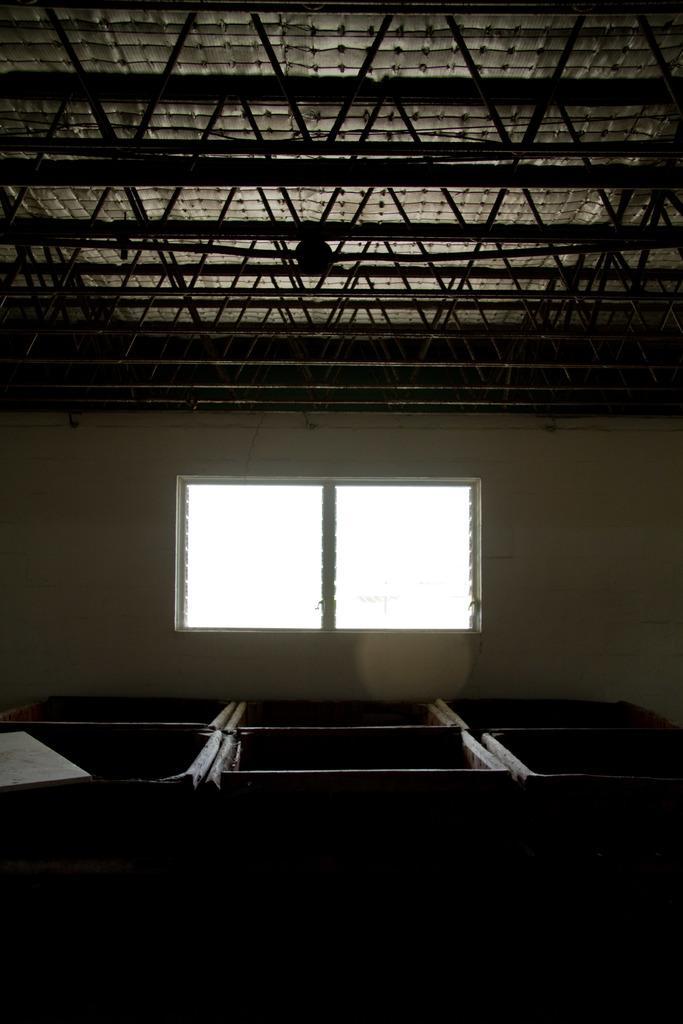Can you describe this image briefly? In this picture, there are some objects in the foreground, there is a window and a roof in the background. 